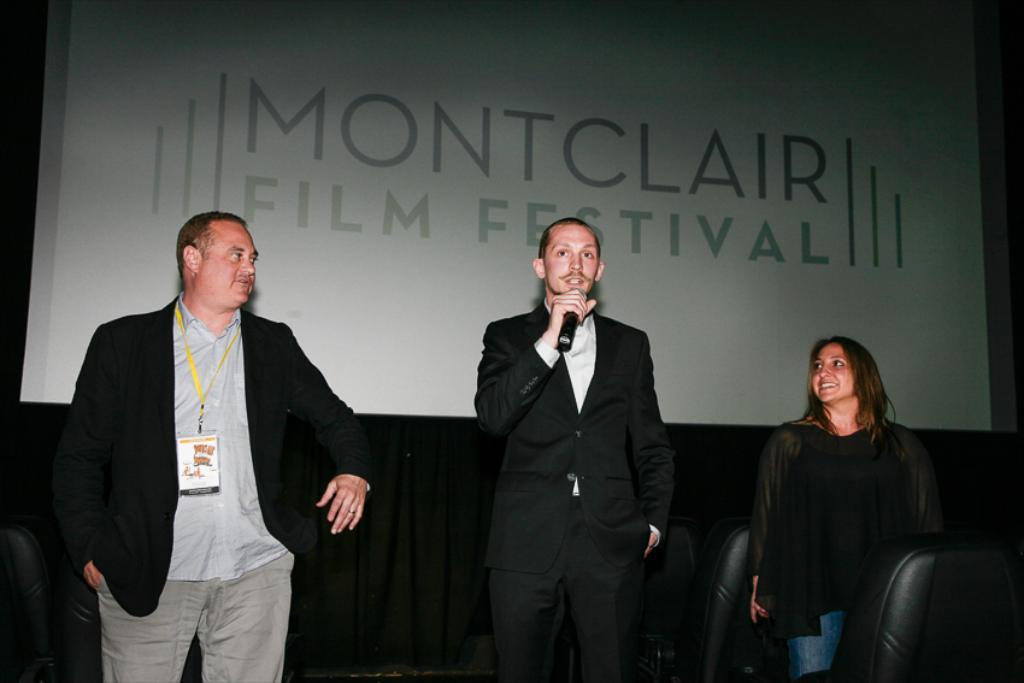How many people are in the image? There are three persons in the image. What is the middle person doing? The middle person is holding a microphone. What can be seen in the background of the image? There is a board in the background of the image. What is written on the board? There is text on the board. What type of zipper can be seen on the microphone in the image? There is no zipper present on the microphone in the image. How does the honey on the board contribute to the conversation in the image? There is no honey present on the board in the image. 